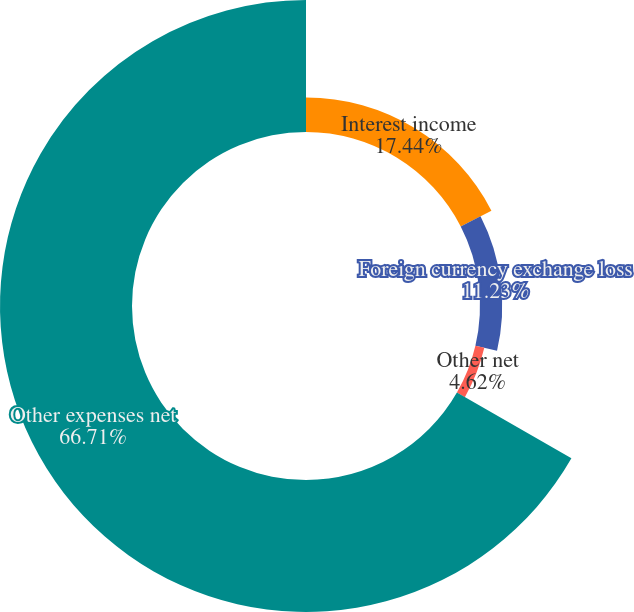<chart> <loc_0><loc_0><loc_500><loc_500><pie_chart><fcel>Interest income<fcel>Foreign currency exchange loss<fcel>Other net<fcel>Other expenses net<nl><fcel>17.44%<fcel>11.23%<fcel>4.62%<fcel>66.71%<nl></chart> 